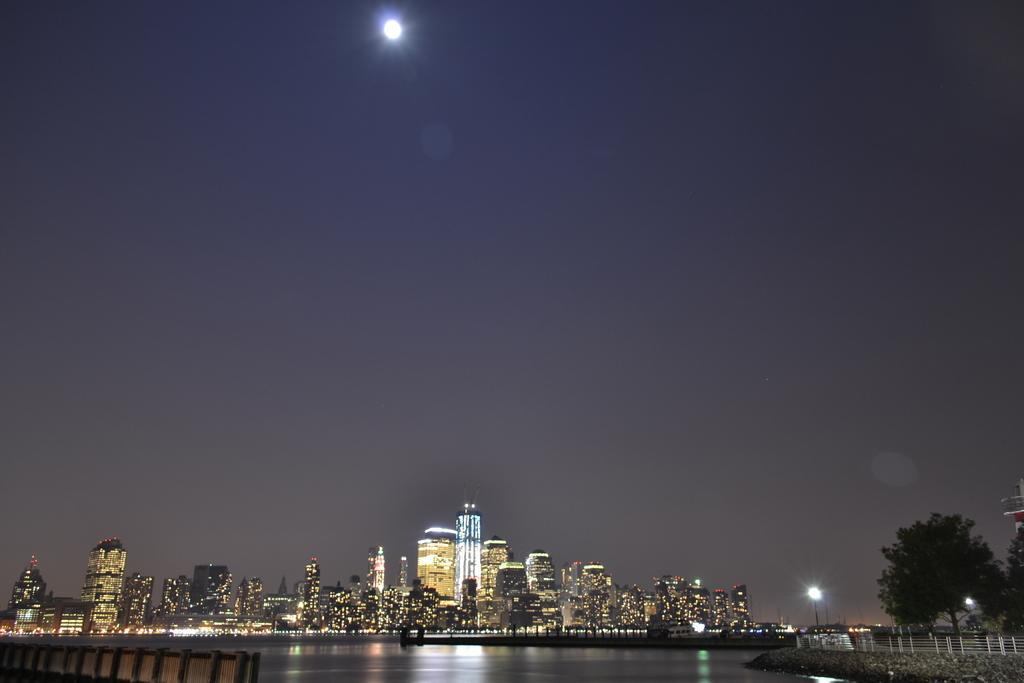Please provide a concise description of this image. In this picture we can see fences, water, buildings, trees, lights and some objects and in the background we can see the sky. 